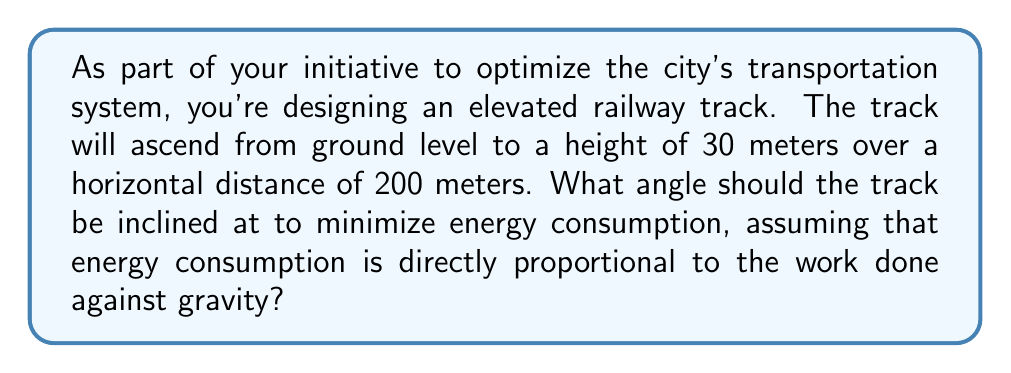Show me your answer to this math problem. To solve this problem, we need to follow these steps:

1) First, we need to understand that the work done against gravity is minimized when the distance traveled along the track is minimized. This occurs when the track follows a straight line from the starting point to the endpoint.

2) We can visualize this as a right-angled triangle, where:
   - The base of the triangle is the horizontal distance (200 m)
   - The height of the triangle is the vertical rise (30 m)
   - The hypotenuse is the track itself

3) We need to find the angle this track makes with the horizontal. We can use the tangent function for this:

   $$\tan(\theta) = \frac{\text{opposite}}{\text{adjacent}} = \frac{\text{rise}}{\text{run}} = \frac{30}{200}$$

4) To find the angle, we take the inverse tangent (arctan or $\tan^{-1}$):

   $$\theta = \tan^{-1}\left(\frac{30}{200}\right)$$

5) Using a calculator or computer:

   $$\theta \approx 8.53^\circ$$

6) We can verify this result by calculating the sine and cosine:

   $$\sin(\theta) = \frac{30}{\sqrt{30^2 + 200^2}} \approx 0.1483$$
   $$\cos(\theta) = \frac{200}{\sqrt{30^2 + 200^2}} \approx 0.9889$$

   Indeed, $\tan(\theta) = \frac{\sin(\theta)}{\cos(\theta)} \approx 0.15 = \frac{30}{200}$

Therefore, the optimal angle for the elevated railway track to minimize energy consumption is approximately 8.53°.

[asy]
import geometry;

size(200);
pair A = (0,0), B = (200,0), C = (0,30);
draw(A--B--C--A);
draw(A--B, arrow=Arrow(TeXHead));
draw(A--C, arrow=Arrow(TeXHead));
label("200 m", (100,0), S);
label("30 m", (0,15), W);
label("$\theta$", (10,3), NE);

[/asy]
Answer: $8.53^\circ$ 